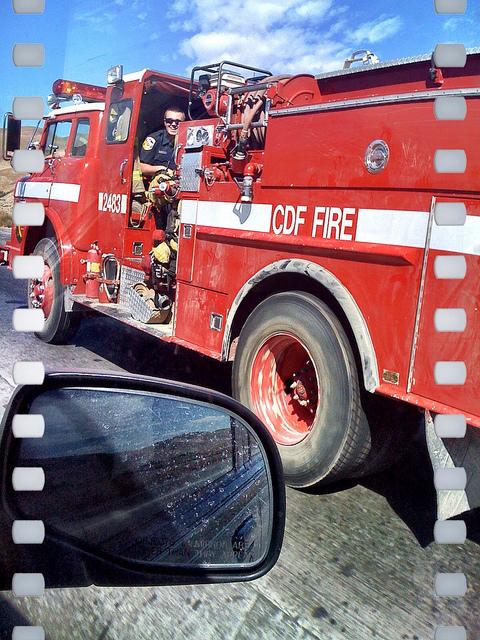Is there a car next to the fire truck?
Concise answer only. Yes. What color is the truck?
Short answer required. Red. What was the person sitting in when they took this photo?
Concise answer only. Car. 